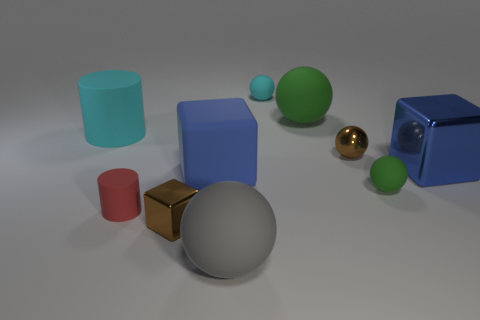Subtract all gray spheres. How many spheres are left? 4 Subtract all tiny brown spheres. How many spheres are left? 4 Subtract all red balls. Subtract all purple cylinders. How many balls are left? 5 Subtract all blocks. How many objects are left? 7 Subtract all small brown rubber objects. Subtract all large rubber cubes. How many objects are left? 9 Add 4 big gray matte objects. How many big gray matte objects are left? 5 Add 4 tiny matte objects. How many tiny matte objects exist? 7 Subtract 1 blue blocks. How many objects are left? 9 